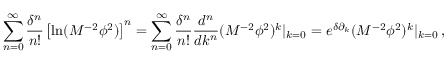<formula> <loc_0><loc_0><loc_500><loc_500>\sum _ { n = 0 } ^ { \infty } \frac { \delta ^ { n } } { n ! } \left [ \ln ( M ^ { - 2 } \phi ^ { 2 } ) \right ] ^ { n } = \sum _ { n = 0 } ^ { \infty } \frac { \delta ^ { n } } { n ! } \frac { d ^ { n } } { d k ^ { n } } ( M ^ { - 2 } \phi ^ { 2 } ) ^ { k } | _ { k = 0 } = e ^ { \delta \partial _ { k } } ( M ^ { - 2 } \phi ^ { 2 } ) ^ { k } | _ { k = 0 } \, ,</formula> 